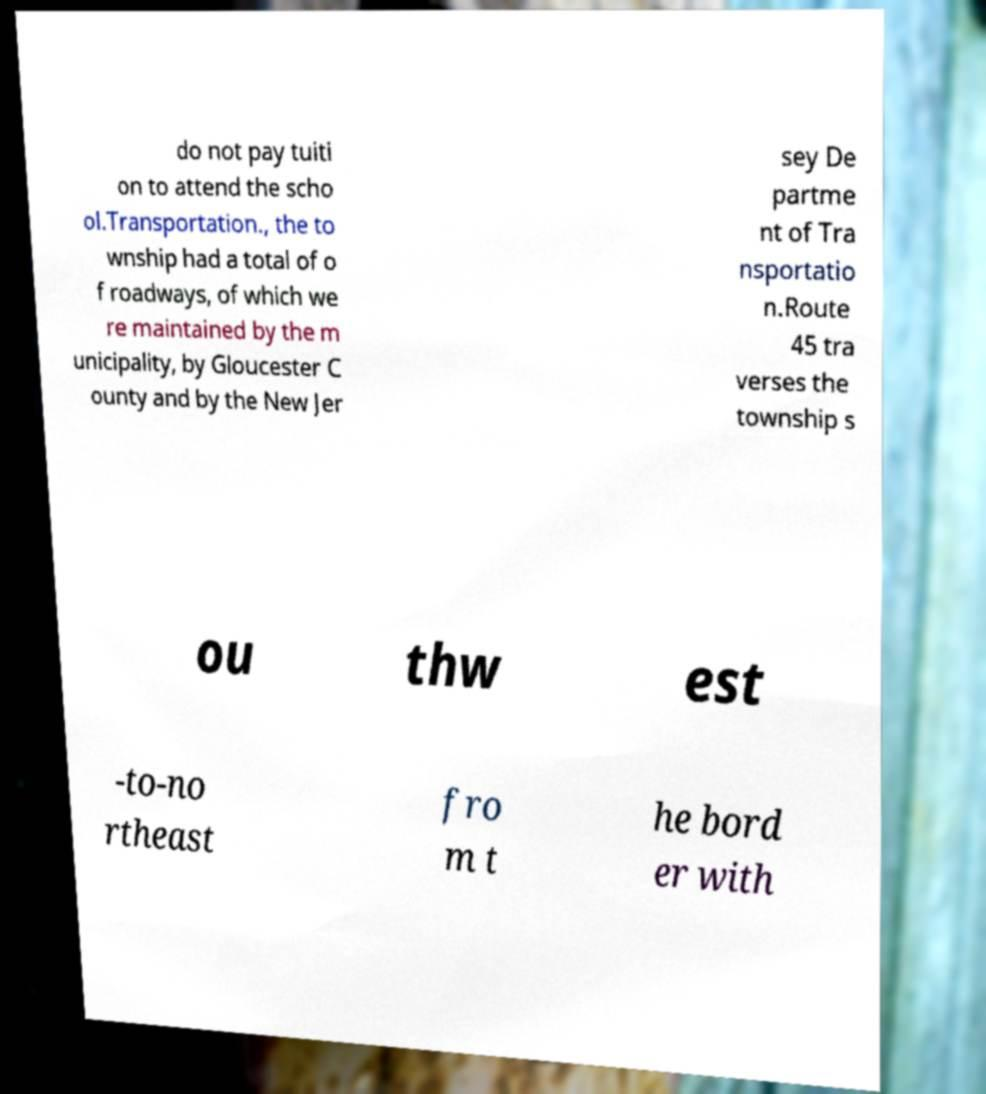Please read and relay the text visible in this image. What does it say? do not pay tuiti on to attend the scho ol.Transportation., the to wnship had a total of o f roadways, of which we re maintained by the m unicipality, by Gloucester C ounty and by the New Jer sey De partme nt of Tra nsportatio n.Route 45 tra verses the township s ou thw est -to-no rtheast fro m t he bord er with 